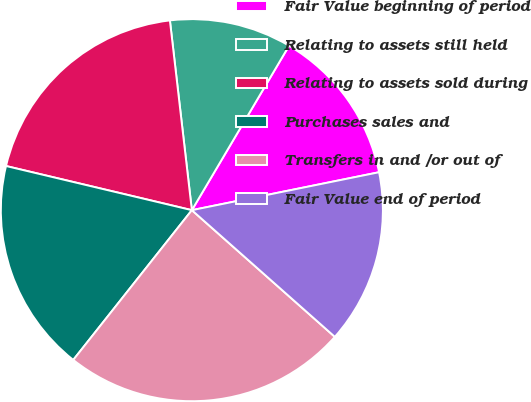Convert chart to OTSL. <chart><loc_0><loc_0><loc_500><loc_500><pie_chart><fcel>Fair Value beginning of period<fcel>Relating to assets still held<fcel>Relating to assets sold during<fcel>Purchases sales and<fcel>Transfers in and /or out of<fcel>Fair Value end of period<nl><fcel>13.32%<fcel>10.33%<fcel>19.45%<fcel>18.05%<fcel>24.12%<fcel>14.72%<nl></chart> 